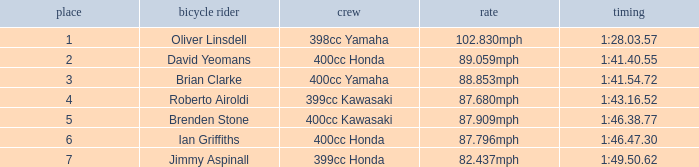What is the time of the rider with a 398cc yamaha? 1:28.03.57. 